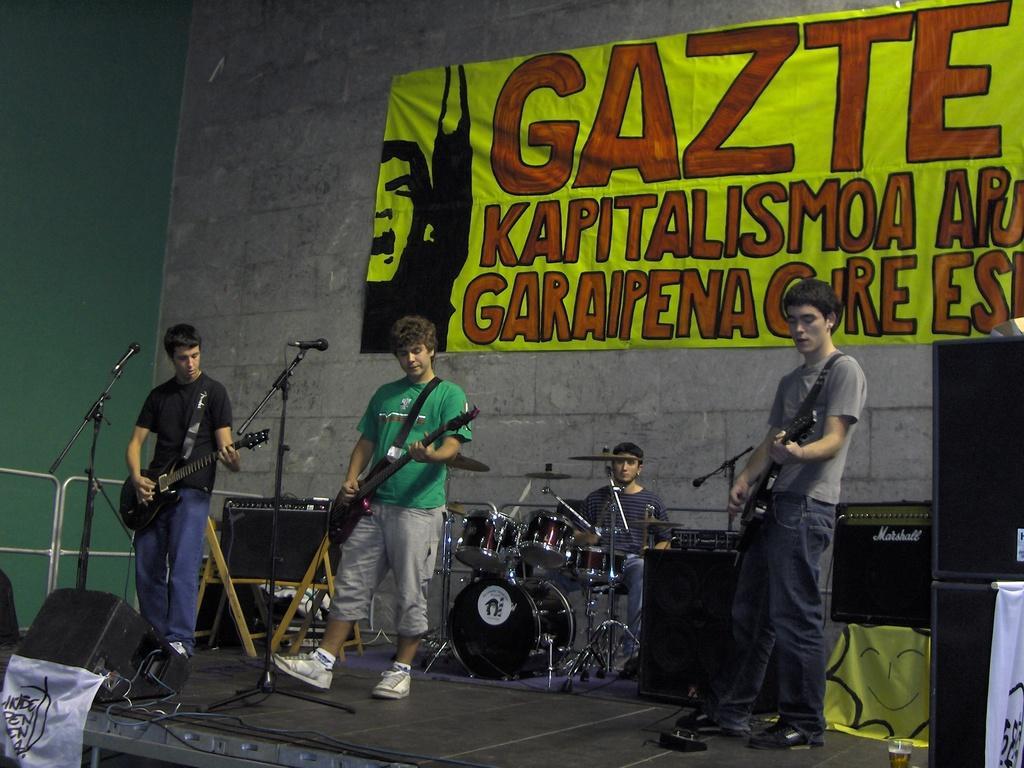Could you give a brief overview of what you see in this image? There are three persons standing and holding guitars and playing. In the back a person is sitting and playing drums. There are mic stands. In the back there's a wall. On the wall there is a banner. There is a speaker on this stage. There are wires on the stage. 